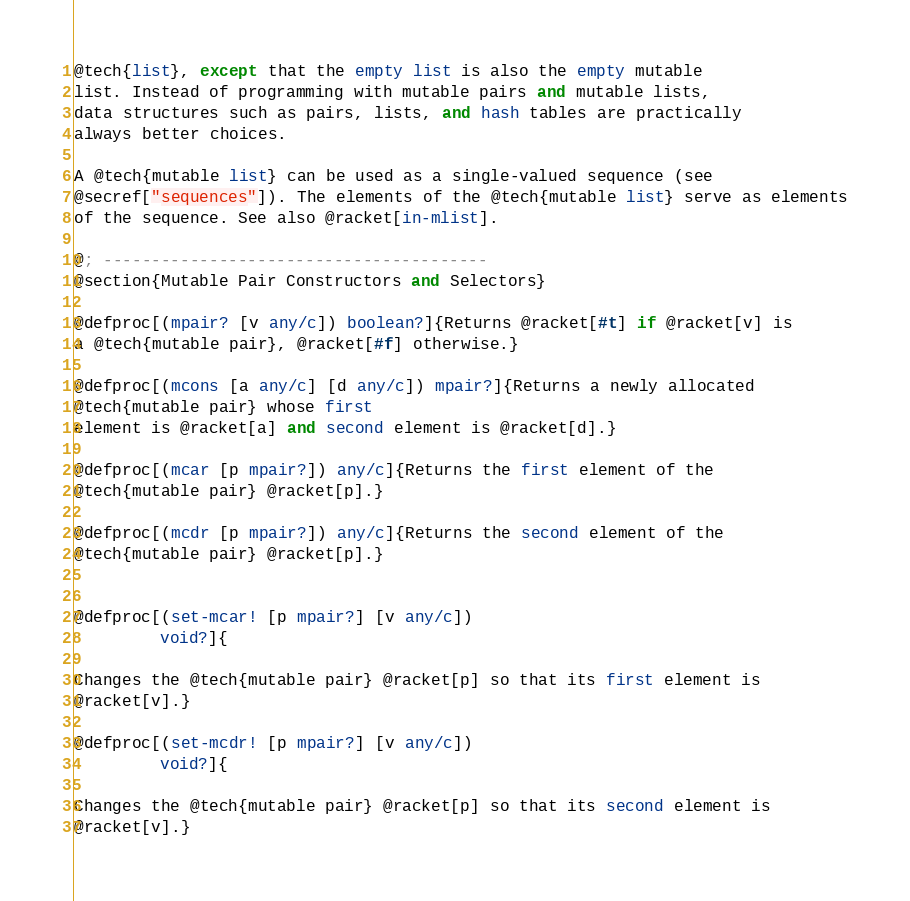<code> <loc_0><loc_0><loc_500><loc_500><_Racket_>@tech{list}, except that the empty list is also the empty mutable
list. Instead of programming with mutable pairs and mutable lists,
data structures such as pairs, lists, and hash tables are practically
always better choices.

A @tech{mutable list} can be used as a single-valued sequence (see
@secref["sequences"]). The elements of the @tech{mutable list} serve as elements
of the sequence. See also @racket[in-mlist].

@; ----------------------------------------
@section{Mutable Pair Constructors and Selectors}

@defproc[(mpair? [v any/c]) boolean?]{Returns @racket[#t] if @racket[v] is
a @tech{mutable pair}, @racket[#f] otherwise.}

@defproc[(mcons [a any/c] [d any/c]) mpair?]{Returns a newly allocated 
@tech{mutable pair} whose first
element is @racket[a] and second element is @racket[d].}

@defproc[(mcar [p mpair?]) any/c]{Returns the first element of the
@tech{mutable pair} @racket[p].}

@defproc[(mcdr [p mpair?]) any/c]{Returns the second element of the
@tech{mutable pair} @racket[p].}


@defproc[(set-mcar! [p mpair?] [v any/c]) 
         void?]{

Changes the @tech{mutable pair} @racket[p] so that its first element is
@racket[v].}

@defproc[(set-mcdr! [p mpair?] [v any/c]) 
         void?]{

Changes the @tech{mutable pair} @racket[p] so that its second element is
@racket[v].}
</code> 